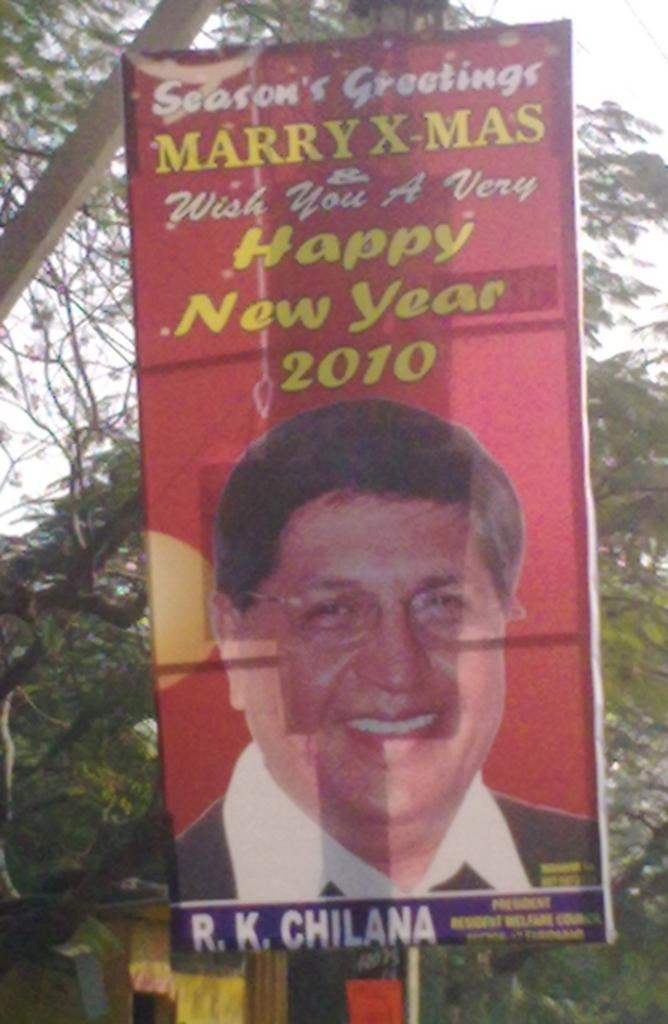What type of vegetation can be seen in the image? There are trees in the image. What object is located in the middle of the image? There is a flexi in the middle of the image. How many bears are visible in the image? There are no bears present in the image. What type of store is shown in the image? There is no store present in the image. 